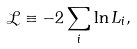<formula> <loc_0><loc_0><loc_500><loc_500>\mathcal { L } \equiv - 2 \sum _ { i } \ln L _ { i } ,</formula> 